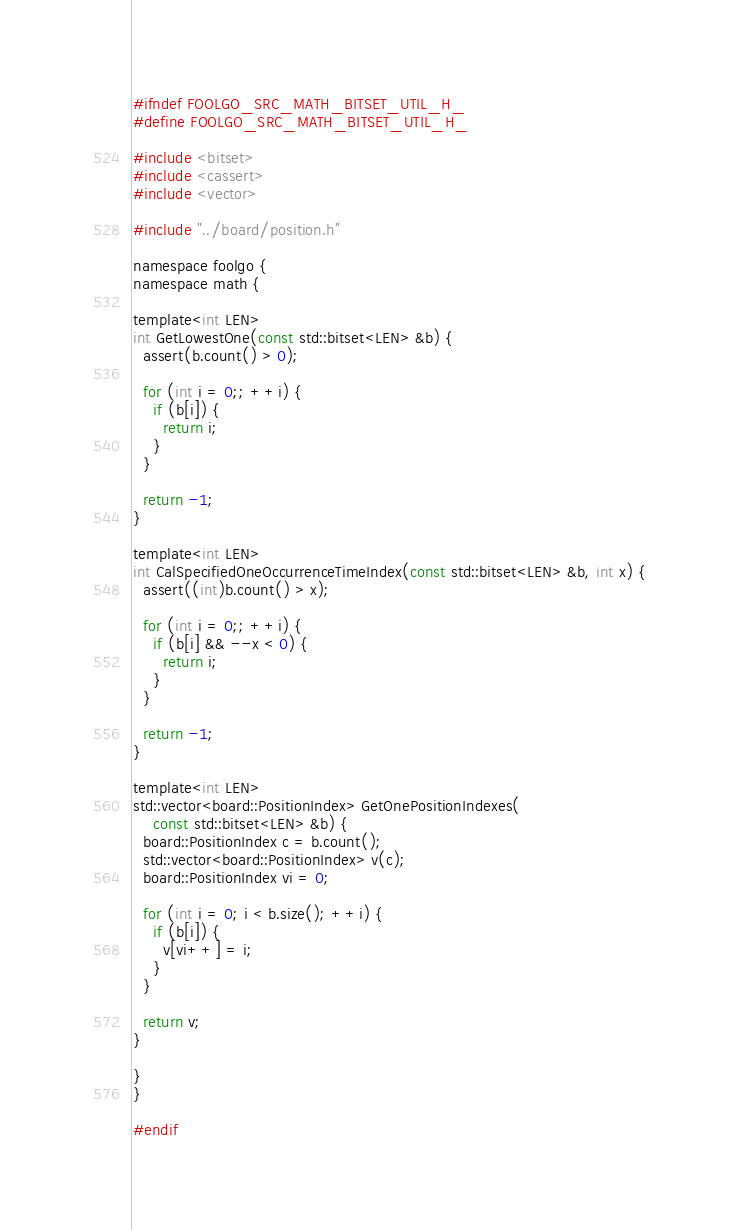Convert code to text. <code><loc_0><loc_0><loc_500><loc_500><_C_>#ifndef FOOLGO_SRC_MATH_BITSET_UTIL_H_
#define FOOLGO_SRC_MATH_BITSET_UTIL_H_

#include <bitset>
#include <cassert>
#include <vector>

#include "../board/position.h"

namespace foolgo {
namespace math {

template<int LEN>
int GetLowestOne(const std::bitset<LEN> &b) {
  assert(b.count() > 0);

  for (int i = 0;; ++i) {
    if (b[i]) {
      return i;
    }
  }

  return -1;
}

template<int LEN>
int CalSpecifiedOneOccurrenceTimeIndex(const std::bitset<LEN> &b, int x) {
  assert((int)b.count() > x);

  for (int i = 0;; ++i) {
    if (b[i] && --x < 0) {
      return i;
    }
  }

  return -1;
}

template<int LEN>
std::vector<board::PositionIndex> GetOnePositionIndexes(
    const std::bitset<LEN> &b) {
  board::PositionIndex c = b.count();
  std::vector<board::PositionIndex> v(c);
  board::PositionIndex vi = 0;

  for (int i = 0; i < b.size(); ++i) {
    if (b[i]) {
      v[vi++] = i;
    }
  }

  return v;
}

}
}

#endif
</code> 